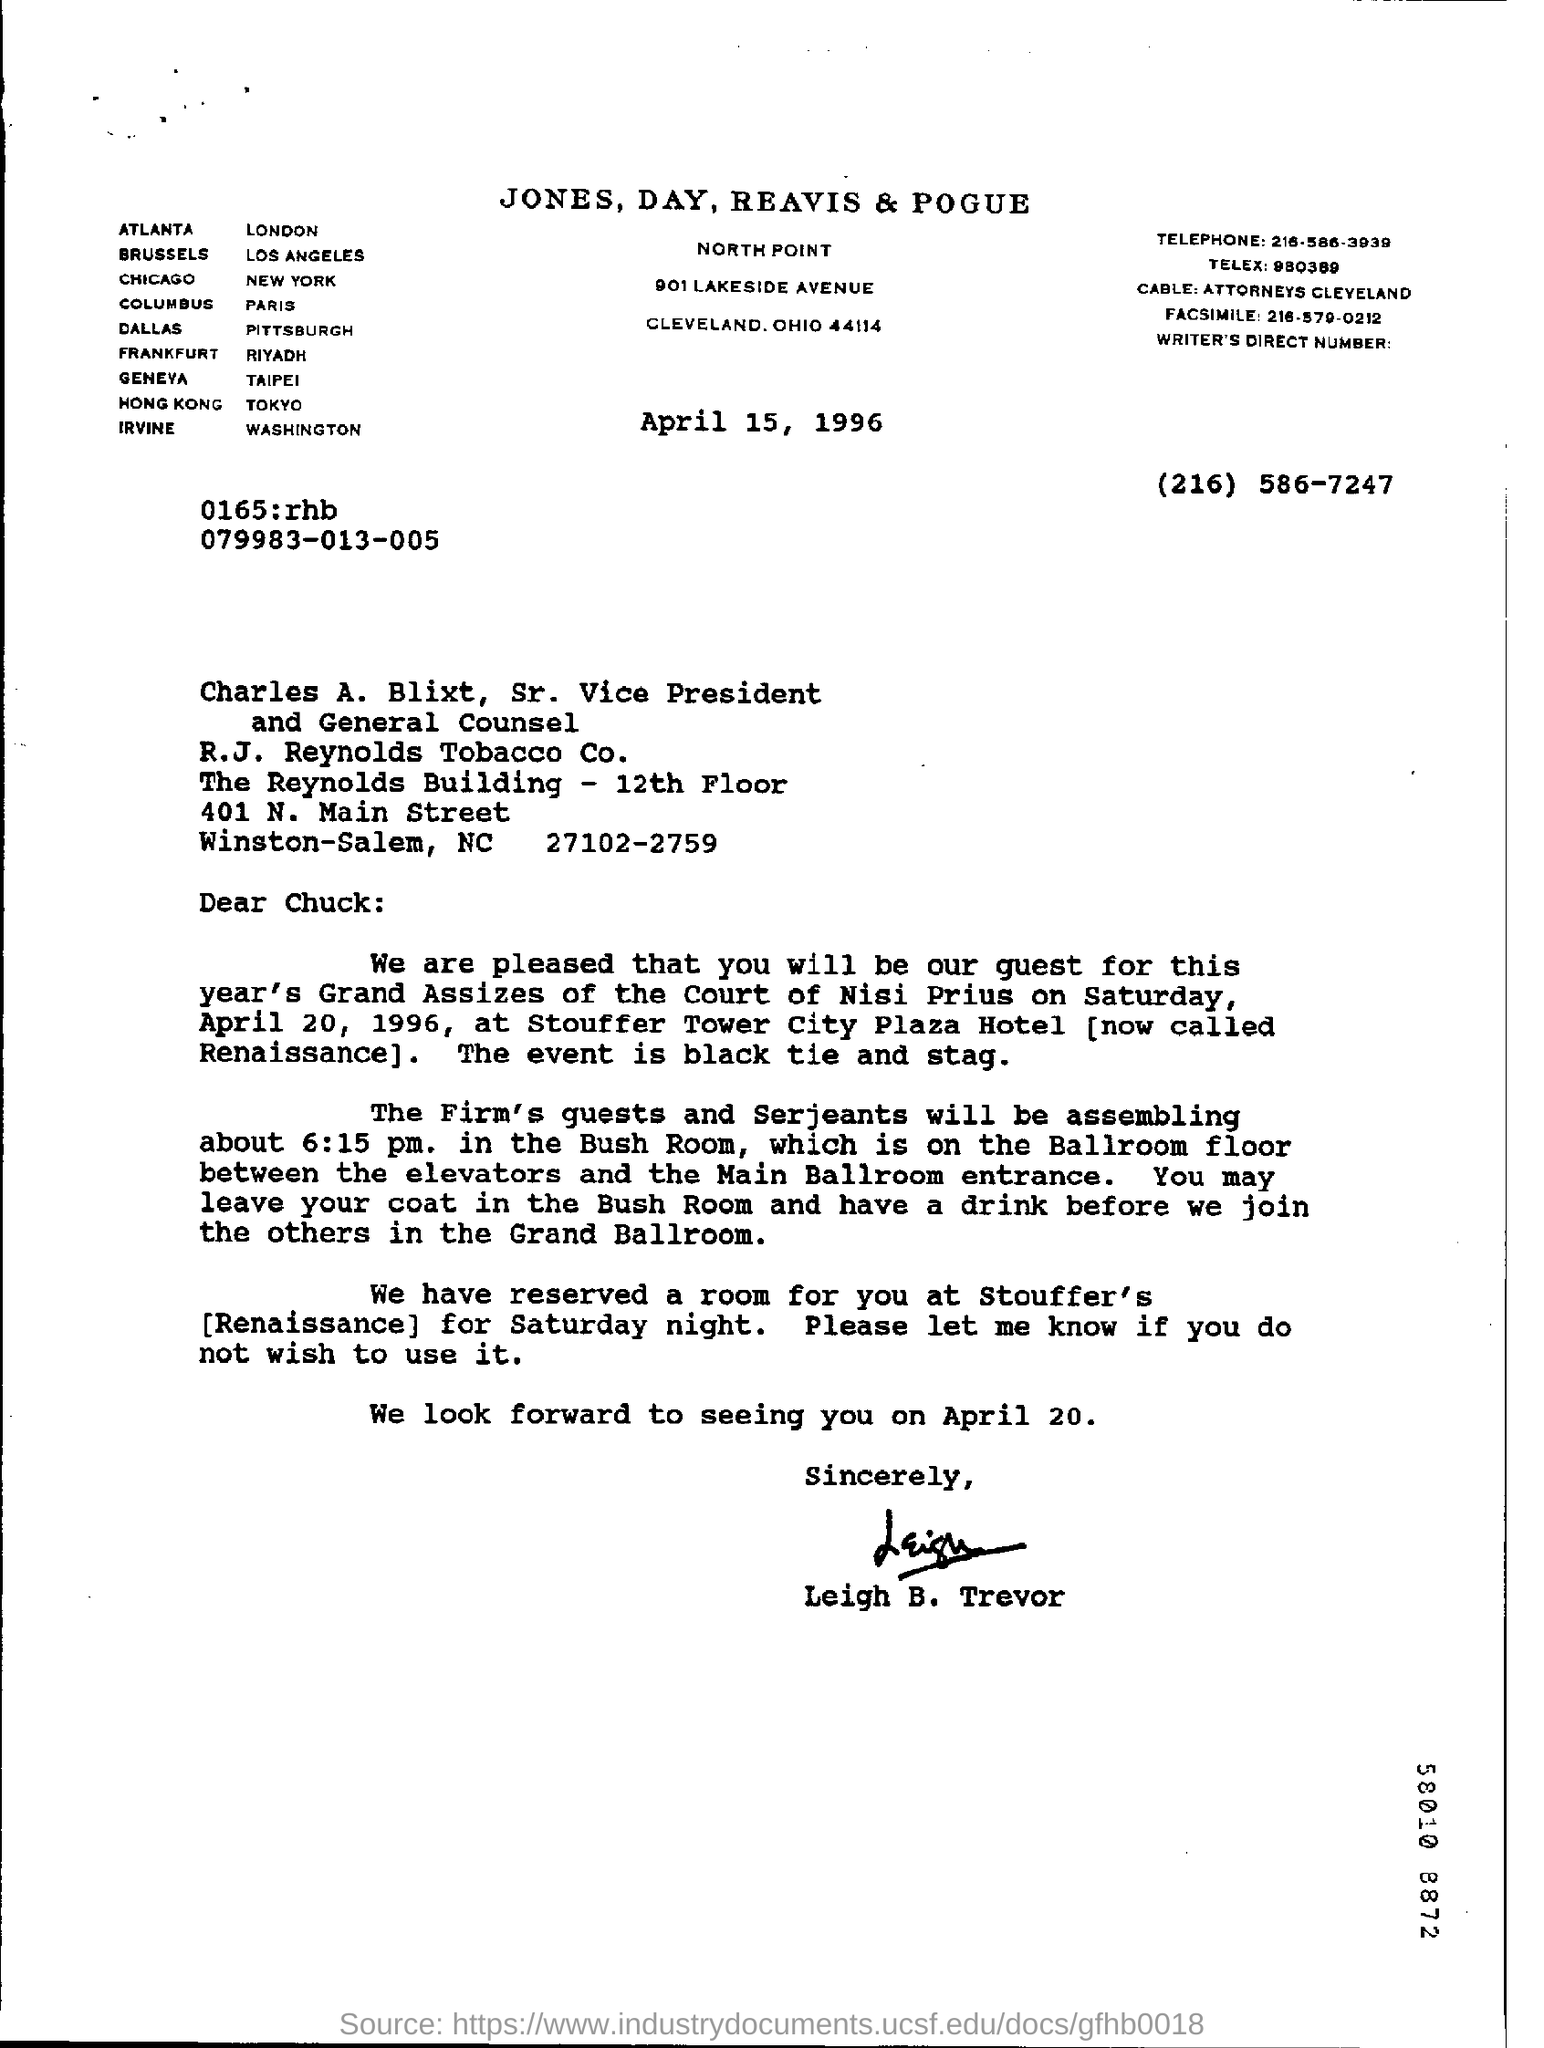Highlight a few significant elements in this photo. The salutation of the letter is "Dear Chuck:... 